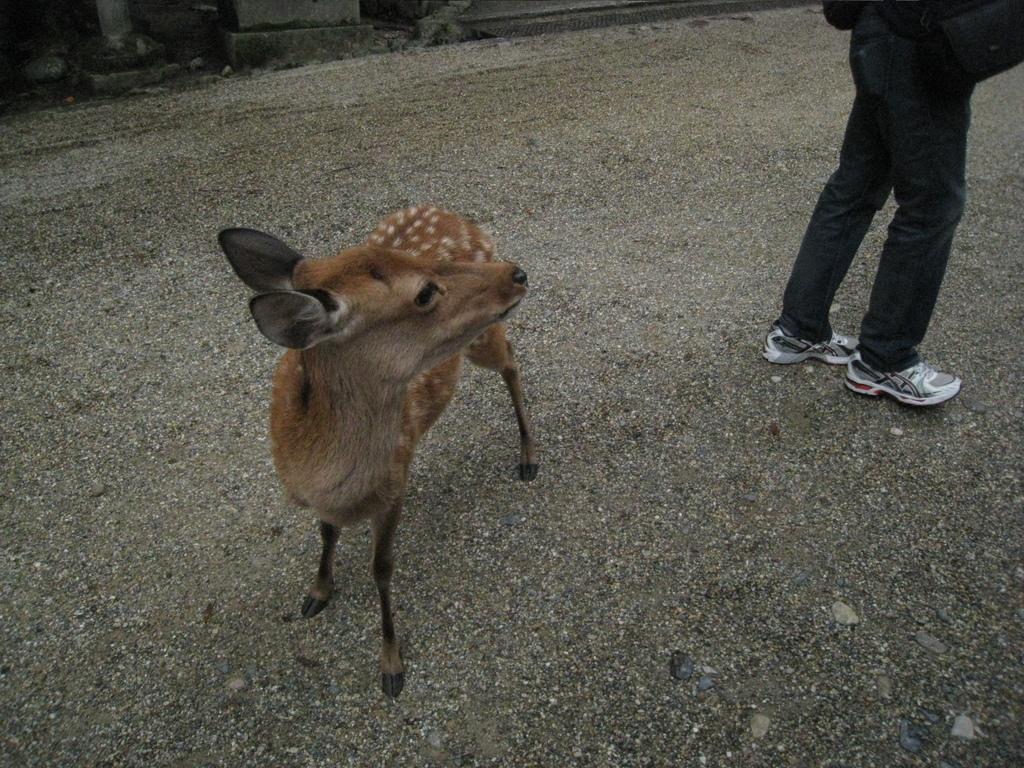Please provide a concise description of this image. In this image I can see an animal and a person on the ground. In the background I can see a fence and stones. This image is taken may be during a day. 